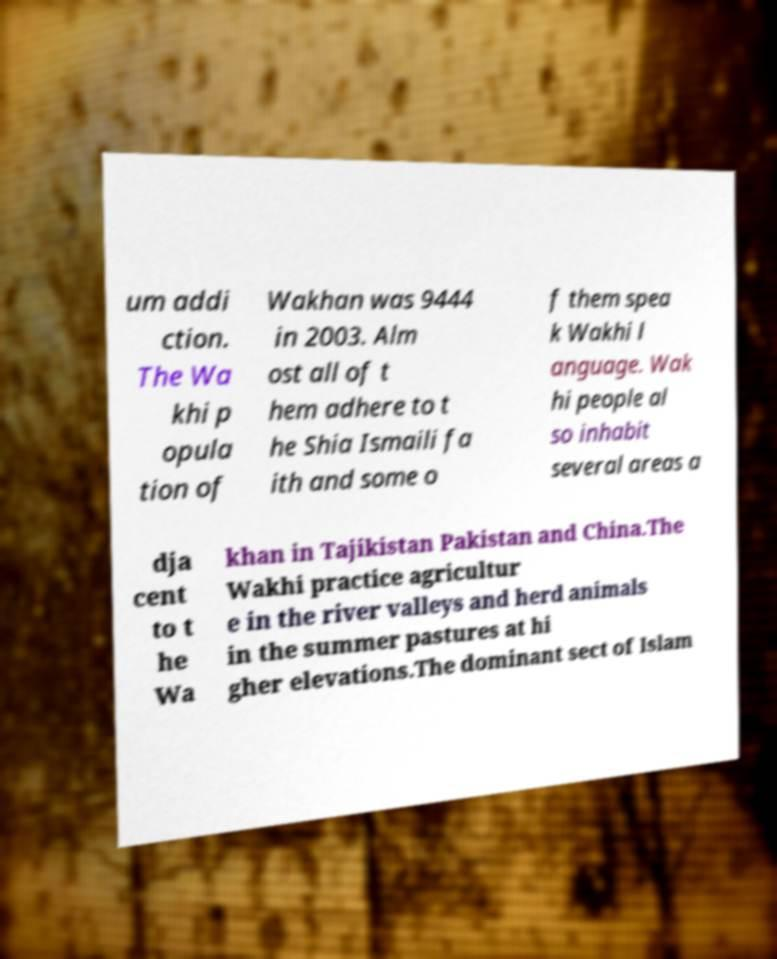I need the written content from this picture converted into text. Can you do that? um addi ction. The Wa khi p opula tion of Wakhan was 9444 in 2003. Alm ost all of t hem adhere to t he Shia Ismaili fa ith and some o f them spea k Wakhi l anguage. Wak hi people al so inhabit several areas a dja cent to t he Wa khan in Tajikistan Pakistan and China.The Wakhi practice agricultur e in the river valleys and herd animals in the summer pastures at hi gher elevations.The dominant sect of Islam 